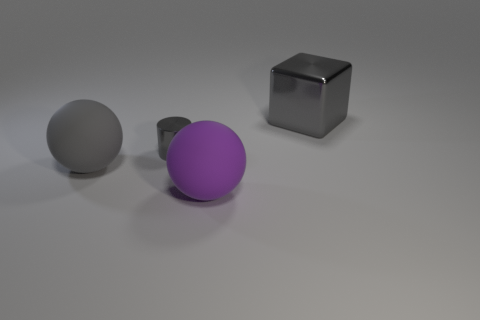What shape is the tiny object that is the same color as the large block?
Keep it short and to the point. Cylinder. Is there another metallic cylinder of the same size as the cylinder?
Keep it short and to the point. No. What color is the thing that is in front of the big gray object to the left of the big object behind the large gray matte ball?
Make the answer very short. Purple. Is the material of the gray ball the same as the large gray object that is right of the gray matte ball?
Your response must be concise. No. Are there the same number of big balls that are to the right of the gray rubber thing and gray metal things that are in front of the big gray cube?
Your answer should be compact. Yes. How many other things are the same material as the big purple thing?
Your answer should be compact. 1. Are there an equal number of matte balls that are behind the big gray shiny object and big cyan cylinders?
Your answer should be very brief. Yes. Does the gray cylinder have the same size as the matte thing that is to the left of the large purple object?
Your response must be concise. No. What is the shape of the big gray object that is in front of the big gray cube?
Keep it short and to the point. Sphere. Is there any other thing that is the same shape as the tiny shiny object?
Ensure brevity in your answer.  No. 